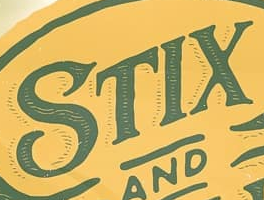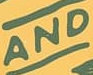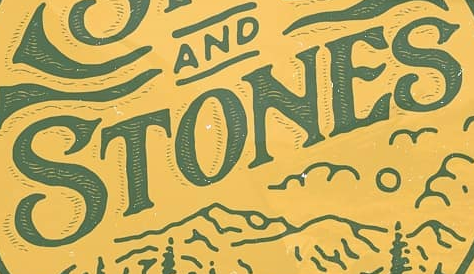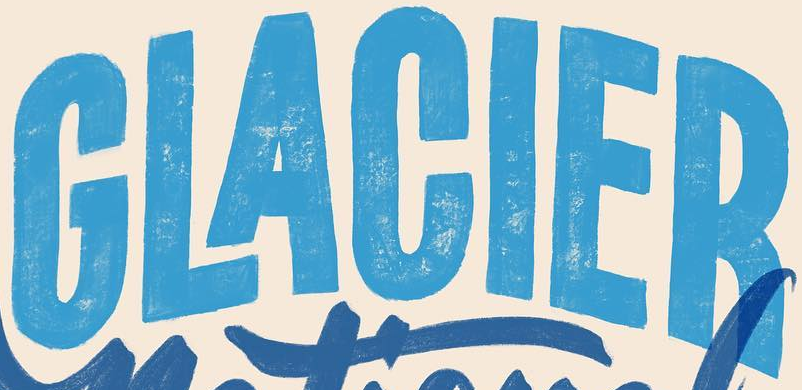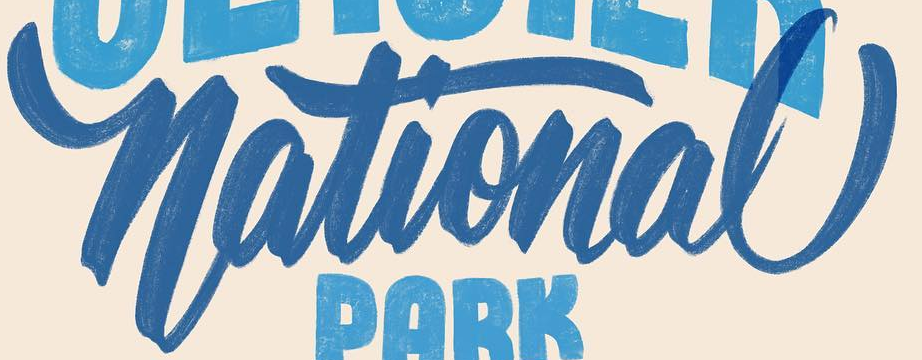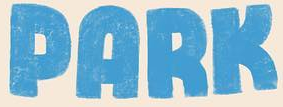Read the text from these images in sequence, separated by a semicolon. STIX; AND; STONES; GLACIER; National; PARK 